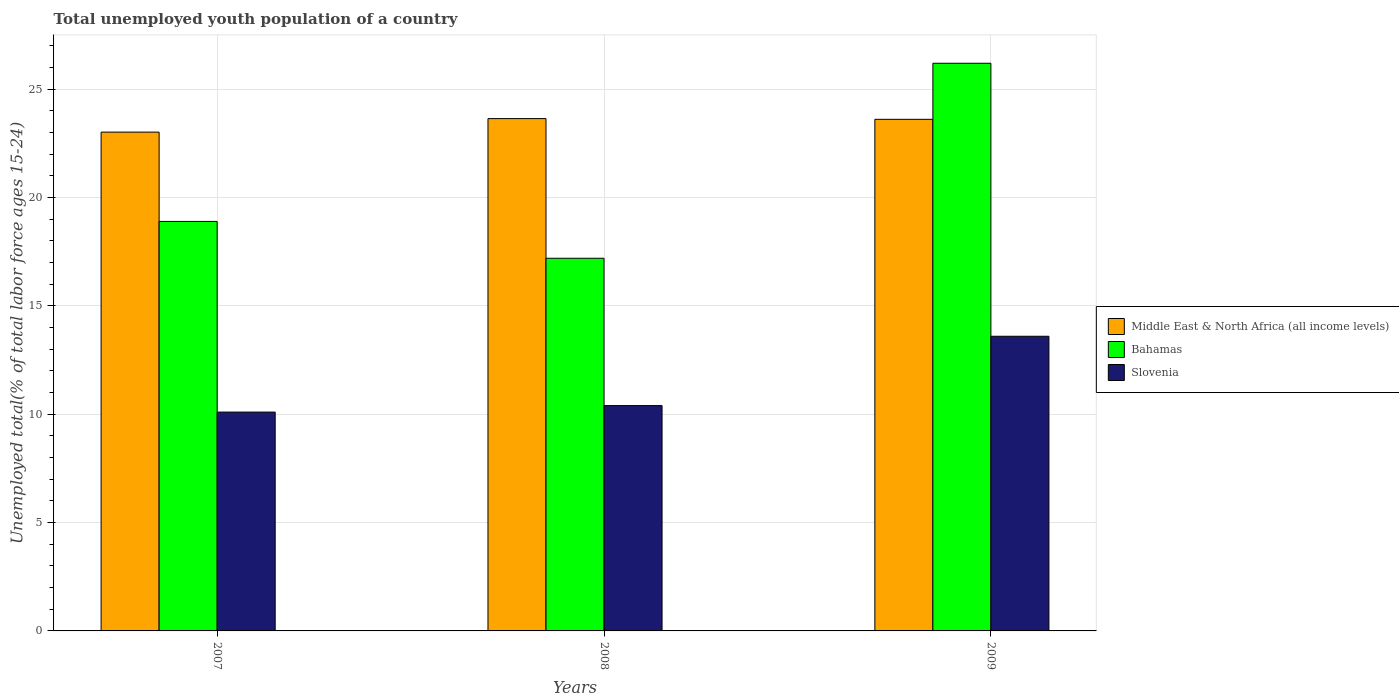How many different coloured bars are there?
Offer a very short reply. 3. How many groups of bars are there?
Your answer should be compact. 3. How many bars are there on the 1st tick from the left?
Offer a terse response. 3. What is the percentage of total unemployed youth population of a country in Slovenia in 2007?
Your response must be concise. 10.1. Across all years, what is the maximum percentage of total unemployed youth population of a country in Bahamas?
Your response must be concise. 26.2. Across all years, what is the minimum percentage of total unemployed youth population of a country in Middle East & North Africa (all income levels)?
Offer a very short reply. 23.02. In which year was the percentage of total unemployed youth population of a country in Bahamas maximum?
Make the answer very short. 2009. In which year was the percentage of total unemployed youth population of a country in Slovenia minimum?
Offer a terse response. 2007. What is the total percentage of total unemployed youth population of a country in Bahamas in the graph?
Your answer should be compact. 62.3. What is the difference between the percentage of total unemployed youth population of a country in Middle East & North Africa (all income levels) in 2007 and that in 2008?
Your answer should be compact. -0.62. What is the difference between the percentage of total unemployed youth population of a country in Slovenia in 2008 and the percentage of total unemployed youth population of a country in Bahamas in 2007?
Give a very brief answer. -8.5. What is the average percentage of total unemployed youth population of a country in Bahamas per year?
Keep it short and to the point. 20.77. In the year 2007, what is the difference between the percentage of total unemployed youth population of a country in Slovenia and percentage of total unemployed youth population of a country in Bahamas?
Provide a short and direct response. -8.8. In how many years, is the percentage of total unemployed youth population of a country in Slovenia greater than 14 %?
Give a very brief answer. 0. What is the ratio of the percentage of total unemployed youth population of a country in Slovenia in 2007 to that in 2009?
Give a very brief answer. 0.74. Is the difference between the percentage of total unemployed youth population of a country in Slovenia in 2007 and 2009 greater than the difference between the percentage of total unemployed youth population of a country in Bahamas in 2007 and 2009?
Keep it short and to the point. Yes. What is the difference between the highest and the second highest percentage of total unemployed youth population of a country in Slovenia?
Your answer should be compact. 3.2. What is the difference between the highest and the lowest percentage of total unemployed youth population of a country in Slovenia?
Provide a short and direct response. 3.5. Is the sum of the percentage of total unemployed youth population of a country in Slovenia in 2007 and 2009 greater than the maximum percentage of total unemployed youth population of a country in Bahamas across all years?
Your response must be concise. No. What does the 2nd bar from the left in 2008 represents?
Your answer should be compact. Bahamas. What does the 2nd bar from the right in 2008 represents?
Provide a succinct answer. Bahamas. What is the difference between two consecutive major ticks on the Y-axis?
Your response must be concise. 5. Where does the legend appear in the graph?
Keep it short and to the point. Center right. How are the legend labels stacked?
Offer a very short reply. Vertical. What is the title of the graph?
Make the answer very short. Total unemployed youth population of a country. Does "Bosnia and Herzegovina" appear as one of the legend labels in the graph?
Provide a succinct answer. No. What is the label or title of the Y-axis?
Ensure brevity in your answer.  Unemployed total(% of total labor force ages 15-24). What is the Unemployed total(% of total labor force ages 15-24) in Middle East & North Africa (all income levels) in 2007?
Your answer should be very brief. 23.02. What is the Unemployed total(% of total labor force ages 15-24) in Bahamas in 2007?
Give a very brief answer. 18.9. What is the Unemployed total(% of total labor force ages 15-24) in Slovenia in 2007?
Your response must be concise. 10.1. What is the Unemployed total(% of total labor force ages 15-24) in Middle East & North Africa (all income levels) in 2008?
Ensure brevity in your answer.  23.65. What is the Unemployed total(% of total labor force ages 15-24) in Bahamas in 2008?
Your response must be concise. 17.2. What is the Unemployed total(% of total labor force ages 15-24) in Slovenia in 2008?
Your response must be concise. 10.4. What is the Unemployed total(% of total labor force ages 15-24) in Middle East & North Africa (all income levels) in 2009?
Your response must be concise. 23.61. What is the Unemployed total(% of total labor force ages 15-24) in Bahamas in 2009?
Offer a terse response. 26.2. What is the Unemployed total(% of total labor force ages 15-24) in Slovenia in 2009?
Provide a succinct answer. 13.6. Across all years, what is the maximum Unemployed total(% of total labor force ages 15-24) of Middle East & North Africa (all income levels)?
Make the answer very short. 23.65. Across all years, what is the maximum Unemployed total(% of total labor force ages 15-24) of Bahamas?
Provide a succinct answer. 26.2. Across all years, what is the maximum Unemployed total(% of total labor force ages 15-24) of Slovenia?
Make the answer very short. 13.6. Across all years, what is the minimum Unemployed total(% of total labor force ages 15-24) of Middle East & North Africa (all income levels)?
Ensure brevity in your answer.  23.02. Across all years, what is the minimum Unemployed total(% of total labor force ages 15-24) of Bahamas?
Give a very brief answer. 17.2. Across all years, what is the minimum Unemployed total(% of total labor force ages 15-24) in Slovenia?
Offer a very short reply. 10.1. What is the total Unemployed total(% of total labor force ages 15-24) of Middle East & North Africa (all income levels) in the graph?
Your response must be concise. 70.28. What is the total Unemployed total(% of total labor force ages 15-24) of Bahamas in the graph?
Your response must be concise. 62.3. What is the total Unemployed total(% of total labor force ages 15-24) in Slovenia in the graph?
Offer a very short reply. 34.1. What is the difference between the Unemployed total(% of total labor force ages 15-24) in Middle East & North Africa (all income levels) in 2007 and that in 2008?
Provide a succinct answer. -0.62. What is the difference between the Unemployed total(% of total labor force ages 15-24) in Bahamas in 2007 and that in 2008?
Your answer should be compact. 1.7. What is the difference between the Unemployed total(% of total labor force ages 15-24) of Middle East & North Africa (all income levels) in 2007 and that in 2009?
Provide a short and direct response. -0.59. What is the difference between the Unemployed total(% of total labor force ages 15-24) of Middle East & North Africa (all income levels) in 2008 and that in 2009?
Give a very brief answer. 0.03. What is the difference between the Unemployed total(% of total labor force ages 15-24) in Bahamas in 2008 and that in 2009?
Provide a short and direct response. -9. What is the difference between the Unemployed total(% of total labor force ages 15-24) in Middle East & North Africa (all income levels) in 2007 and the Unemployed total(% of total labor force ages 15-24) in Bahamas in 2008?
Offer a very short reply. 5.82. What is the difference between the Unemployed total(% of total labor force ages 15-24) of Middle East & North Africa (all income levels) in 2007 and the Unemployed total(% of total labor force ages 15-24) of Slovenia in 2008?
Your answer should be very brief. 12.62. What is the difference between the Unemployed total(% of total labor force ages 15-24) of Middle East & North Africa (all income levels) in 2007 and the Unemployed total(% of total labor force ages 15-24) of Bahamas in 2009?
Give a very brief answer. -3.18. What is the difference between the Unemployed total(% of total labor force ages 15-24) of Middle East & North Africa (all income levels) in 2007 and the Unemployed total(% of total labor force ages 15-24) of Slovenia in 2009?
Ensure brevity in your answer.  9.42. What is the difference between the Unemployed total(% of total labor force ages 15-24) of Middle East & North Africa (all income levels) in 2008 and the Unemployed total(% of total labor force ages 15-24) of Bahamas in 2009?
Your answer should be compact. -2.55. What is the difference between the Unemployed total(% of total labor force ages 15-24) in Middle East & North Africa (all income levels) in 2008 and the Unemployed total(% of total labor force ages 15-24) in Slovenia in 2009?
Provide a succinct answer. 10.05. What is the difference between the Unemployed total(% of total labor force ages 15-24) in Bahamas in 2008 and the Unemployed total(% of total labor force ages 15-24) in Slovenia in 2009?
Make the answer very short. 3.6. What is the average Unemployed total(% of total labor force ages 15-24) of Middle East & North Africa (all income levels) per year?
Your answer should be very brief. 23.43. What is the average Unemployed total(% of total labor force ages 15-24) in Bahamas per year?
Your response must be concise. 20.77. What is the average Unemployed total(% of total labor force ages 15-24) in Slovenia per year?
Make the answer very short. 11.37. In the year 2007, what is the difference between the Unemployed total(% of total labor force ages 15-24) in Middle East & North Africa (all income levels) and Unemployed total(% of total labor force ages 15-24) in Bahamas?
Provide a succinct answer. 4.12. In the year 2007, what is the difference between the Unemployed total(% of total labor force ages 15-24) of Middle East & North Africa (all income levels) and Unemployed total(% of total labor force ages 15-24) of Slovenia?
Offer a very short reply. 12.92. In the year 2008, what is the difference between the Unemployed total(% of total labor force ages 15-24) in Middle East & North Africa (all income levels) and Unemployed total(% of total labor force ages 15-24) in Bahamas?
Make the answer very short. 6.45. In the year 2008, what is the difference between the Unemployed total(% of total labor force ages 15-24) of Middle East & North Africa (all income levels) and Unemployed total(% of total labor force ages 15-24) of Slovenia?
Your response must be concise. 13.25. In the year 2009, what is the difference between the Unemployed total(% of total labor force ages 15-24) in Middle East & North Africa (all income levels) and Unemployed total(% of total labor force ages 15-24) in Bahamas?
Offer a terse response. -2.59. In the year 2009, what is the difference between the Unemployed total(% of total labor force ages 15-24) of Middle East & North Africa (all income levels) and Unemployed total(% of total labor force ages 15-24) of Slovenia?
Provide a succinct answer. 10.01. What is the ratio of the Unemployed total(% of total labor force ages 15-24) of Middle East & North Africa (all income levels) in 2007 to that in 2008?
Give a very brief answer. 0.97. What is the ratio of the Unemployed total(% of total labor force ages 15-24) in Bahamas in 2007 to that in 2008?
Your answer should be compact. 1.1. What is the ratio of the Unemployed total(% of total labor force ages 15-24) in Slovenia in 2007 to that in 2008?
Your answer should be compact. 0.97. What is the ratio of the Unemployed total(% of total labor force ages 15-24) in Bahamas in 2007 to that in 2009?
Your answer should be very brief. 0.72. What is the ratio of the Unemployed total(% of total labor force ages 15-24) of Slovenia in 2007 to that in 2009?
Your answer should be compact. 0.74. What is the ratio of the Unemployed total(% of total labor force ages 15-24) in Middle East & North Africa (all income levels) in 2008 to that in 2009?
Your response must be concise. 1. What is the ratio of the Unemployed total(% of total labor force ages 15-24) of Bahamas in 2008 to that in 2009?
Provide a succinct answer. 0.66. What is the ratio of the Unemployed total(% of total labor force ages 15-24) in Slovenia in 2008 to that in 2009?
Make the answer very short. 0.76. What is the difference between the highest and the second highest Unemployed total(% of total labor force ages 15-24) in Middle East & North Africa (all income levels)?
Your response must be concise. 0.03. What is the difference between the highest and the second highest Unemployed total(% of total labor force ages 15-24) in Bahamas?
Ensure brevity in your answer.  7.3. What is the difference between the highest and the second highest Unemployed total(% of total labor force ages 15-24) of Slovenia?
Ensure brevity in your answer.  3.2. What is the difference between the highest and the lowest Unemployed total(% of total labor force ages 15-24) of Middle East & North Africa (all income levels)?
Make the answer very short. 0.62. 